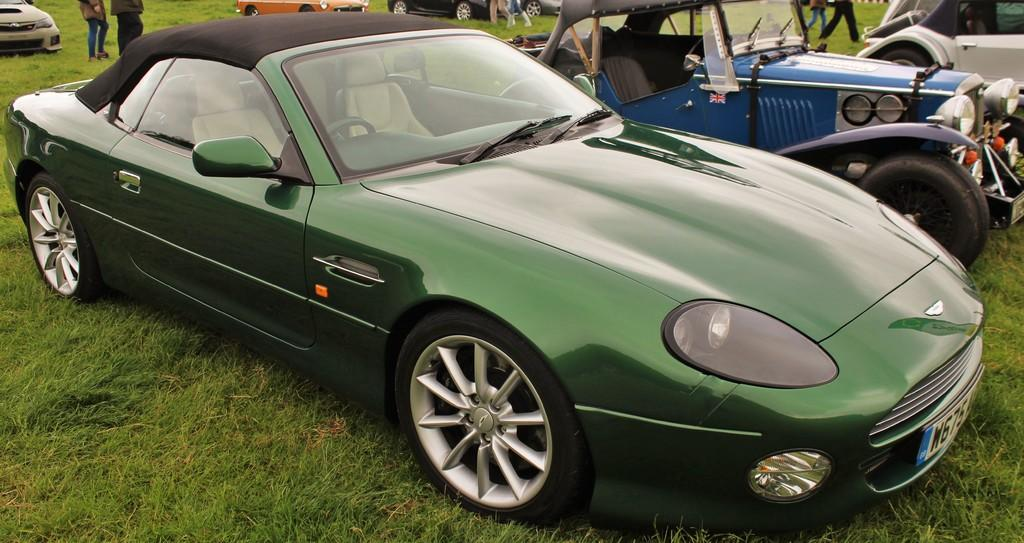Where was the image taken? The image was clicked outside. What can be seen in the center of the image? There are vehicles parked on the ground in the center of the image. Can you describe the people visible in the image? There is a group of people visible in the image. What type of vegetation is present in the image? Green grass is present in the image. What else can be seen in the image besides the vehicles and people? There are other objects in the image. What color are the toes of the person in the image? There are no visible toes in the image, as the people are not close enough for their feet to be seen. 